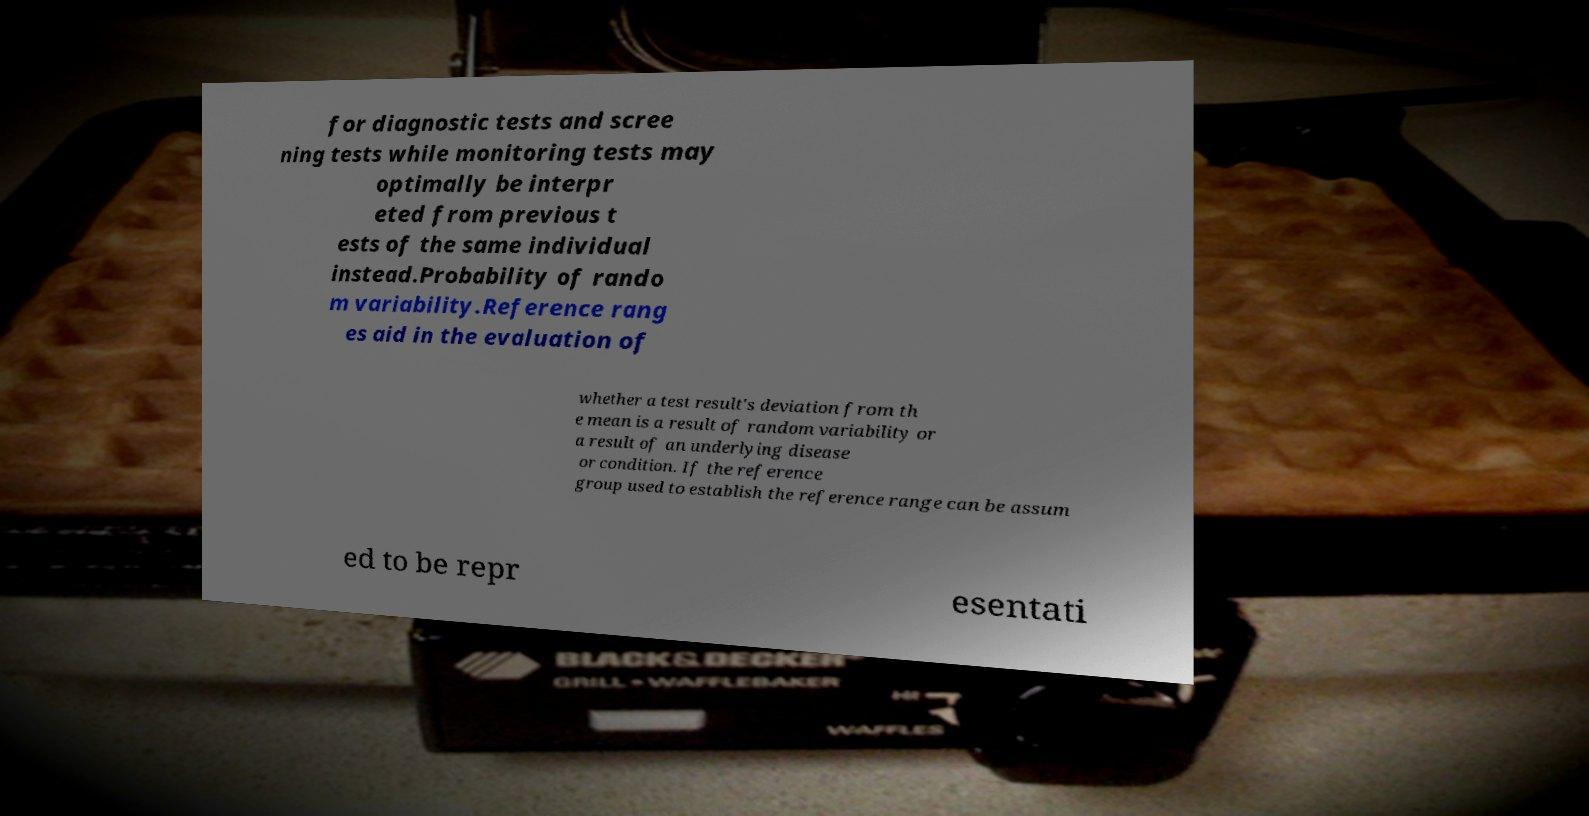There's text embedded in this image that I need extracted. Can you transcribe it verbatim? for diagnostic tests and scree ning tests while monitoring tests may optimally be interpr eted from previous t ests of the same individual instead.Probability of rando m variability.Reference rang es aid in the evaluation of whether a test result's deviation from th e mean is a result of random variability or a result of an underlying disease or condition. If the reference group used to establish the reference range can be assum ed to be repr esentati 